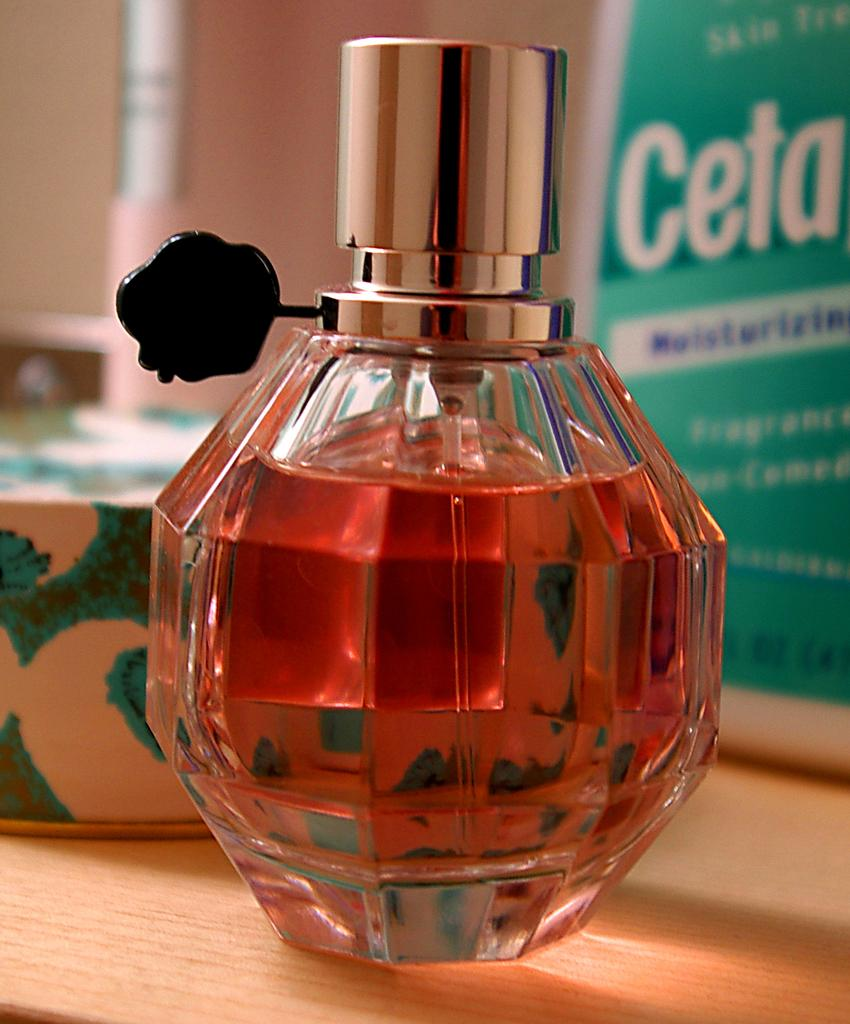Provide a one-sentence caption for the provided image. The bottle of perfume sits in front of another bottle that has the letters "Ceta". 